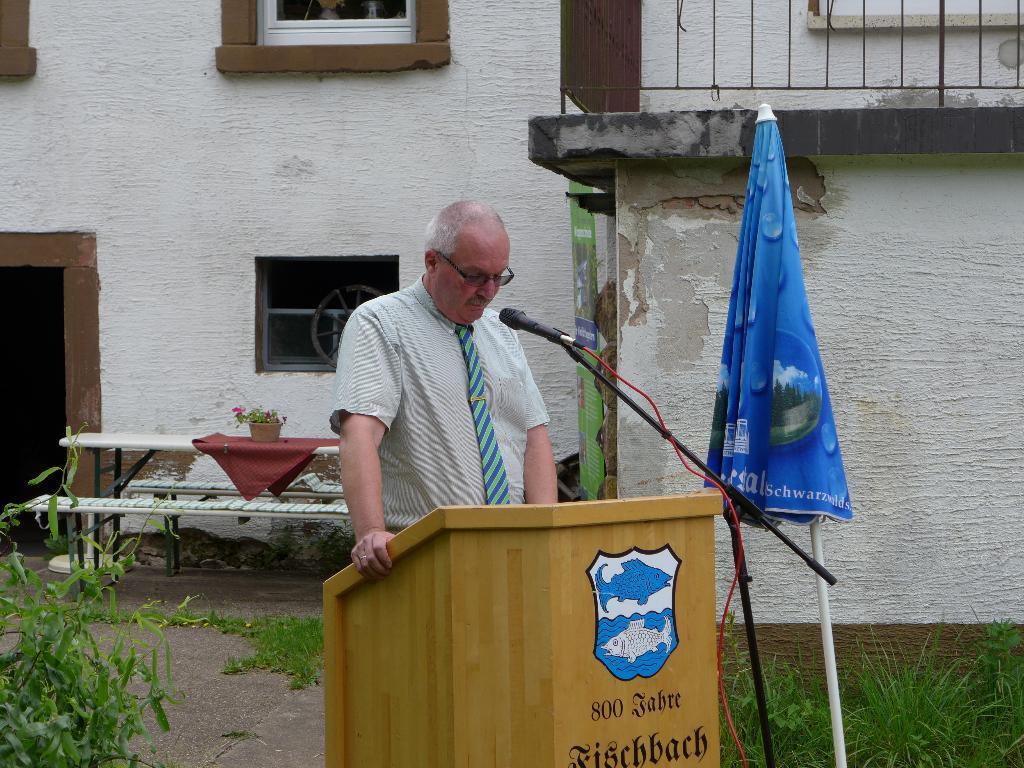How would you summarize this image in a sentence or two? On the background there is a wall with windows and door. on the bench we can see a flower pot. We can see one man standing in front of a mic and podium. This is an umbrella. At the right and left side of the picture we can see plants. 